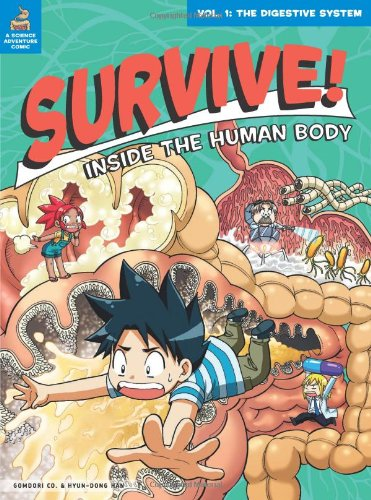What is the title of this book? The title of this vivid and engaging book is 'Survive! Inside the Human Body, Vol. 1: The Digestive System'. It's a journey through human biology designed for young readers! 